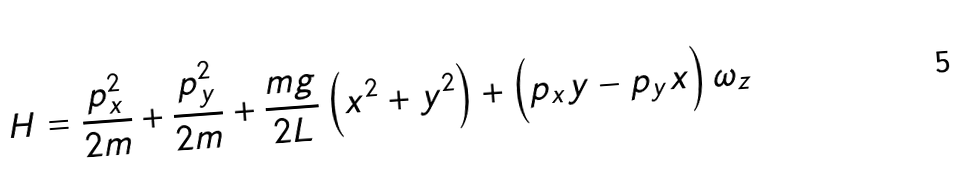<formula> <loc_0><loc_0><loc_500><loc_500>H = \frac { p _ { x } ^ { 2 } } { 2 m } + \frac { p _ { y } ^ { 2 } } { 2 m } + \frac { m g } { 2 L } \left ( x ^ { 2 } + y ^ { 2 } \Big . \right ) + \left ( p _ { x } y - p _ { y } x \Big . \right ) \omega _ { z }</formula> 